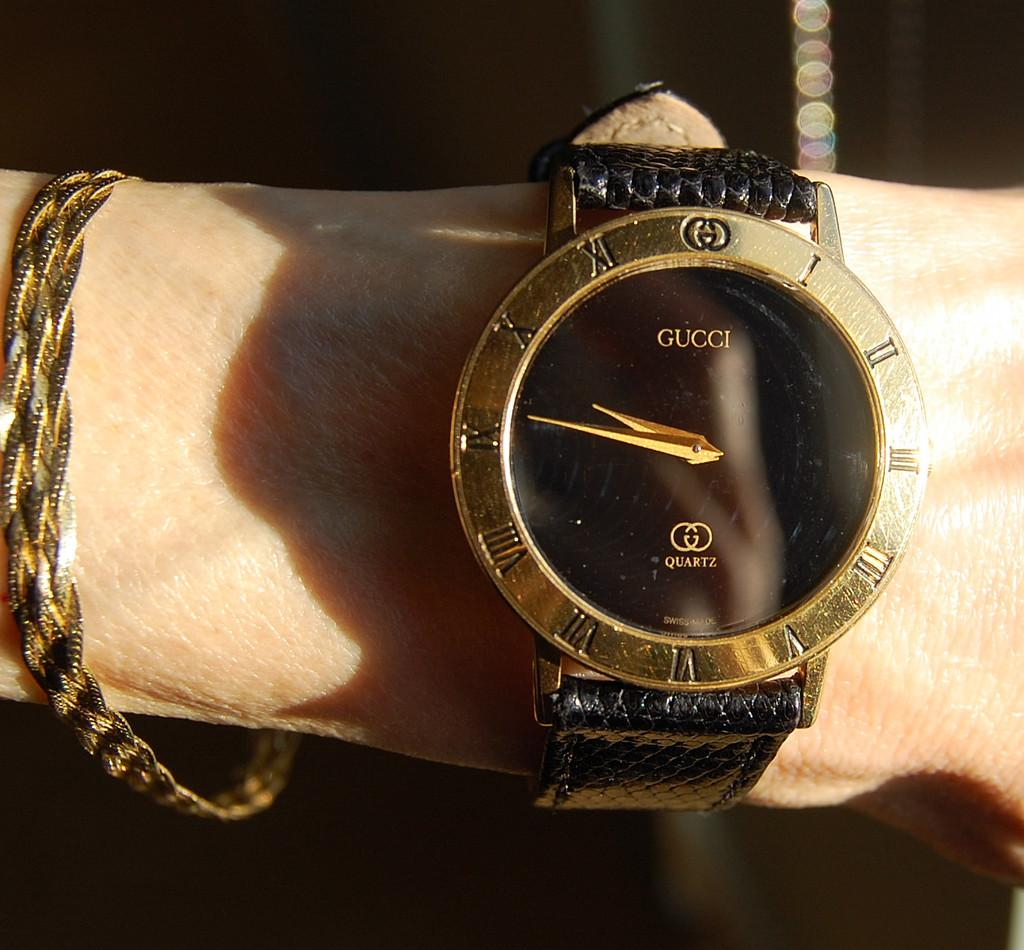<image>
Offer a succinct explanation of the picture presented. A Gucci watch has an empty black face other than saying it has a quartz movement. 